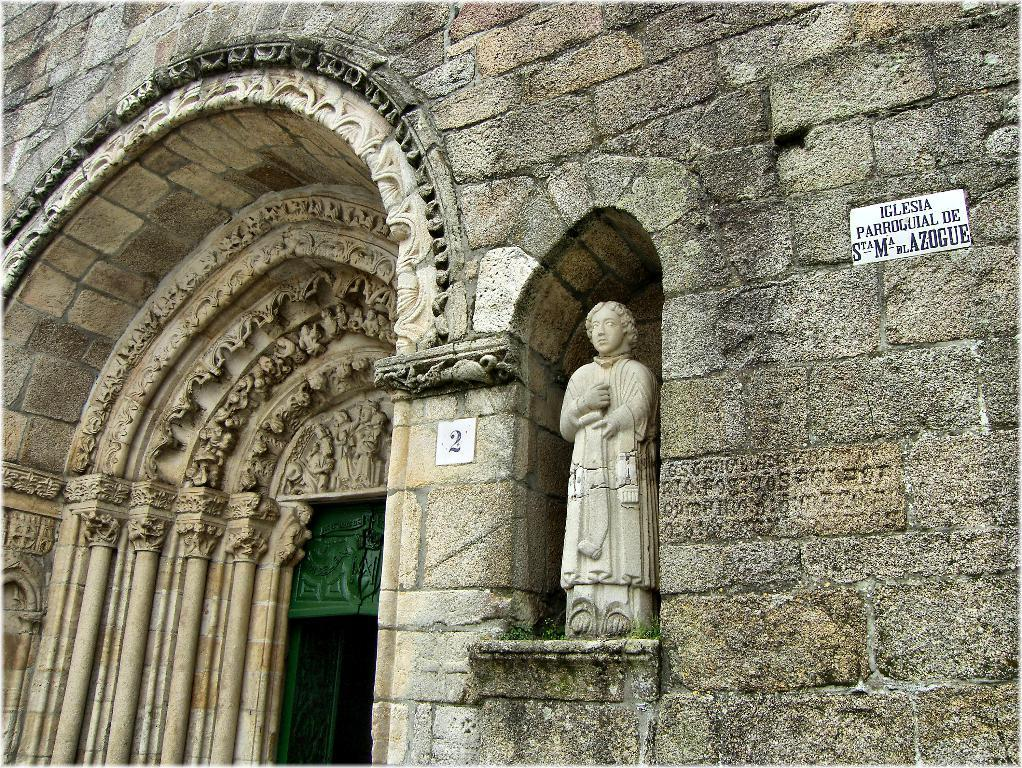What type of scene is depicted in the image? The image is an outside view of a building. What can be seen on the building in the image? There is a name board with text and a board with a number on a wall in the image. Are there any other objects or features visible in the image? Yes, there is a statue in the image. What type of hat is the statue wearing in the image? There is no mention of a hat or any other clothing in the provided facts. Additionally, the statue is not described as wearing anything. 